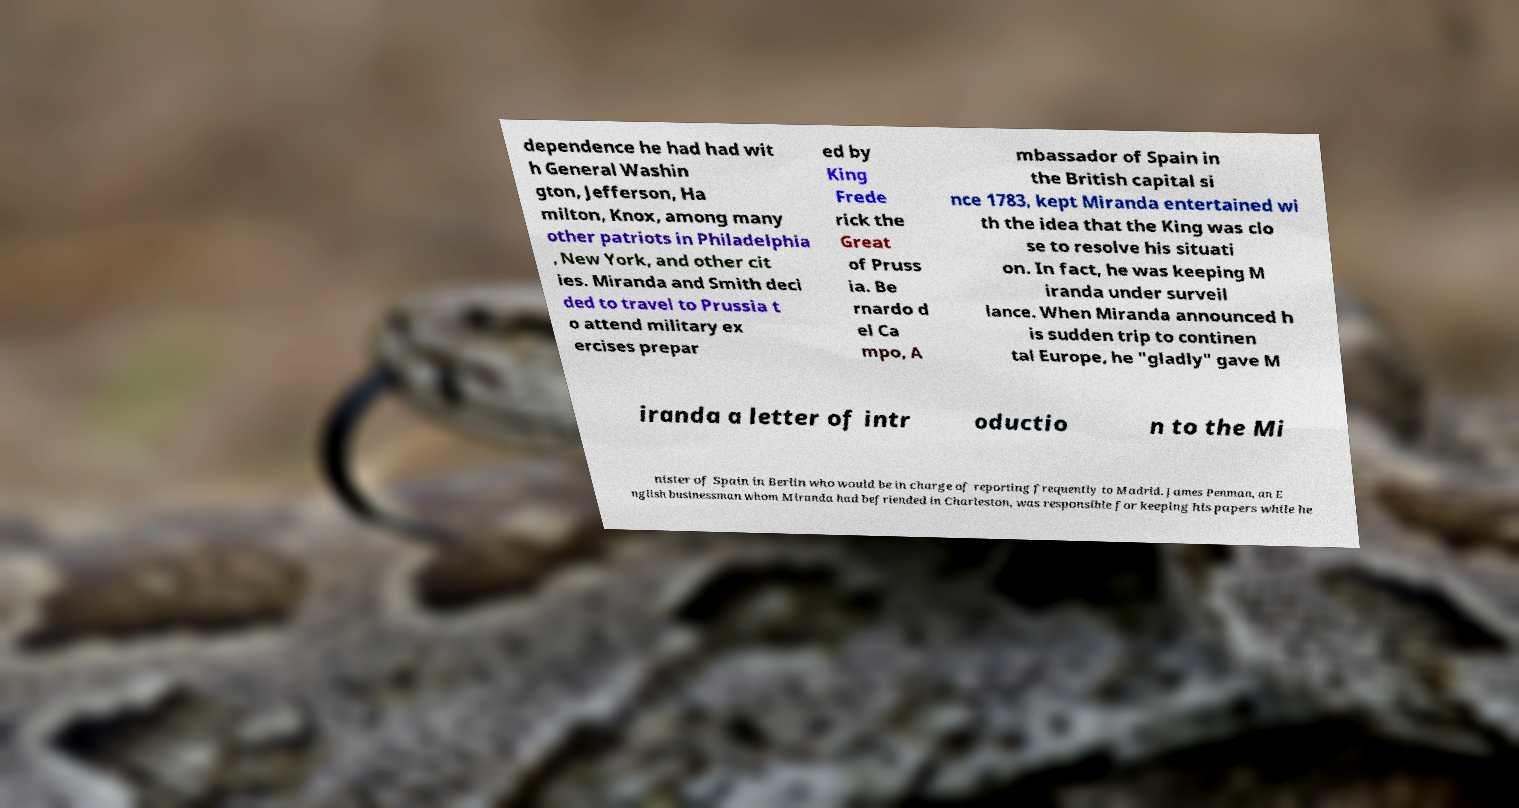There's text embedded in this image that I need extracted. Can you transcribe it verbatim? dependence he had had wit h General Washin gton, Jefferson, Ha milton, Knox, among many other patriots in Philadelphia , New York, and other cit ies. Miranda and Smith deci ded to travel to Prussia t o attend military ex ercises prepar ed by King Frede rick the Great of Pruss ia. Be rnardo d el Ca mpo, A mbassador of Spain in the British capital si nce 1783, kept Miranda entertained wi th the idea that the King was clo se to resolve his situati on. In fact, he was keeping M iranda under surveil lance. When Miranda announced h is sudden trip to continen tal Europe, he "gladly" gave M iranda a letter of intr oductio n to the Mi nister of Spain in Berlin who would be in charge of reporting frequently to Madrid. James Penman, an E nglish businessman whom Miranda had befriended in Charleston, was responsible for keeping his papers while he 